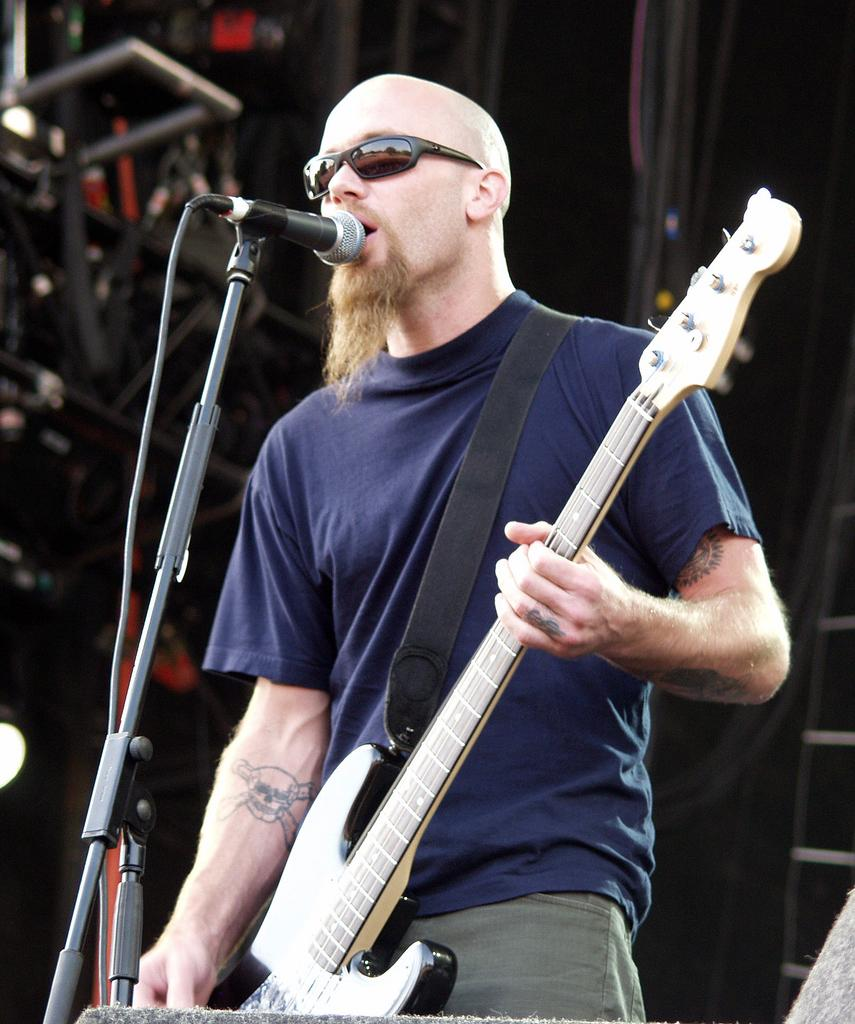What object is located at the front of the image? There is a microphone in the front of the image. What is the person in the center of the image doing? The person is singing and holding a musical instrument. Can you describe the background of the image? The background of the image is blurry. What type of dock can be seen in the background of the image? There is no dock present in the image; the background is blurry. Can you tell me how many halls are visible in the image? There is no mention of a hall in the image; it features a microphone, a person singing, and a blurry background. 